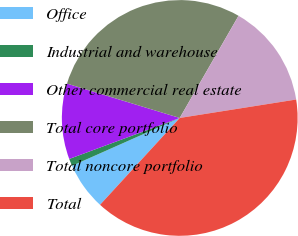Convert chart to OTSL. <chart><loc_0><loc_0><loc_500><loc_500><pie_chart><fcel>Office<fcel>Industrial and warehouse<fcel>Other commercial real estate<fcel>Total core portfolio<fcel>Total noncore portfolio<fcel>Total<nl><fcel>6.53%<fcel>1.0%<fcel>10.36%<fcel>28.61%<fcel>14.19%<fcel>39.32%<nl></chart> 